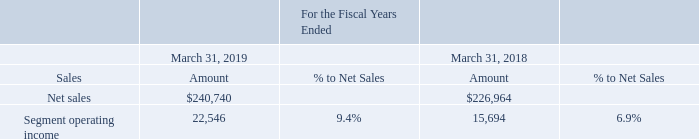Electro-Magnetic, Sensors, and Actuators
The following table sets forth net sales, operating income, and operating income as a percentage of net sales for our MSA reportable segment in fiscal years 2019 and 2018 (amounts in thousands, except percentages).
Net Sales MSA net sales of $240.7 million in fiscal year 2019 increased $13.8 million or 6.1% from $227.0 million in fiscal year 2018. The increase in net sales was primarily driven by a $15.0 million increase in OEM sales in the JPKO region. Also contributing to the increase in net sales was a $4.3 million increase in EMS sales across all regions and a $3.7 million increase in distributor sales across the Americas and EMEA regions. These increase in net sales were partially offset by a $5.5 million decrease in distributor sales across the APAC and JPKO regions and a $3.8 million decrease in OEM sales across the Americas, APAC, and JPKO regions.
Reportable Segment Operating Income
Segment operating income of $22.5 million in fiscal year 2019 increased $6.9 million from $15.7 million in fiscal year 2018. The increase in operating income was primarily due to a $6.6 million decrease in SG&A expenses resulting from a decrease in payroll expenses that was caused by a reduction in head count. Also contributing to the increase in operating income was a $2.9 million decrease in restructuring charges, a $1.3 million decrease in net loss on write down and disposal of long-lived assets, and a $0.2 million decrease in R&D expenses. Partially offsetting these improvements was a $4.1 million decrease in gross margin, which was primarily driven by a change in the sales mix to lower margin products.
What was the main driver of MSA net sales increase between 2018 and 2019? Primarily driven by a $15.0 million increase in oem sales in the jpko region. What was the net sales in 2019?
Answer scale should be: thousand. 240,740. Which years does the table provide information for the net sales, operating income, and operating income as a percentage of net sales for the company's MSA segment? 2019, 2018. What was the change in the percentage to net sales between 2018 and 2019?
Answer scale should be: percent. 9.4-6.9
Answer: 2.5. Which years did net sales exceed $200,000 thousand? (2019:240,740),(2018:226,964)
Answer: 2019, 2018. What was the percentage change in segment operating income between 2018 and 2019?
Answer scale should be: percent. (22,546-15,694)/15,694
Answer: 43.66. 